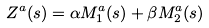Convert formula to latex. <formula><loc_0><loc_0><loc_500><loc_500>Z ^ { a } ( s ) = \alpha M _ { 1 } ^ { a } ( s ) + \beta M _ { 2 } ^ { a } ( s )</formula> 